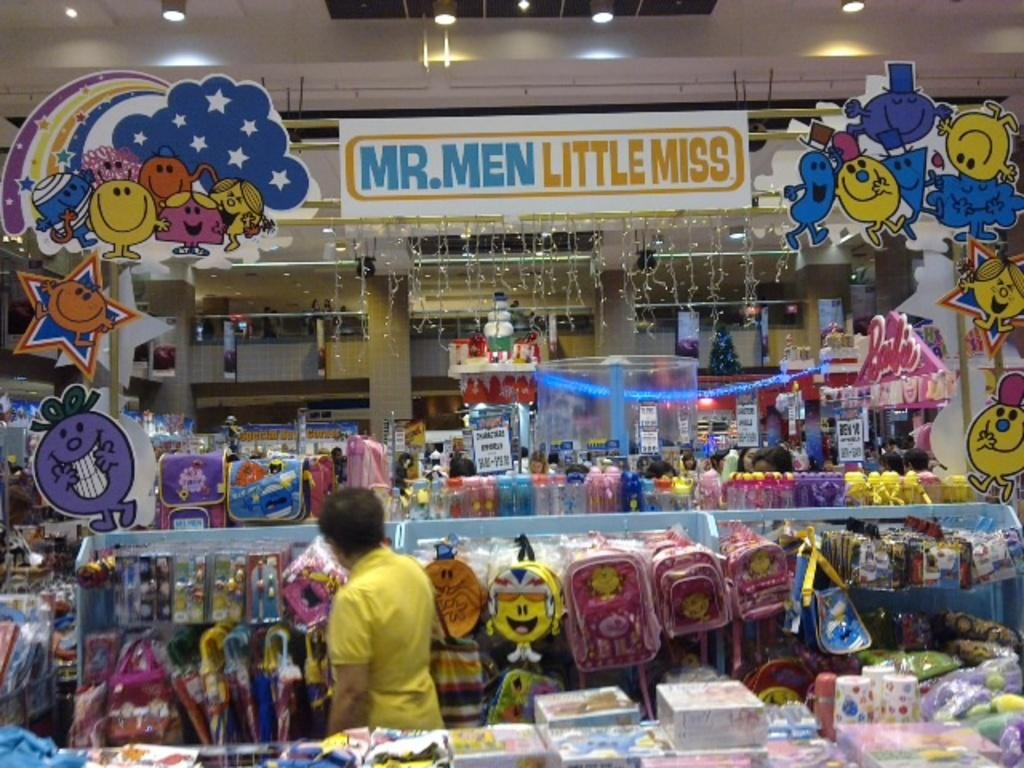<image>
Provide a brief description of the given image. The theme of that section of the store was Mr. Men and Little Miss. 